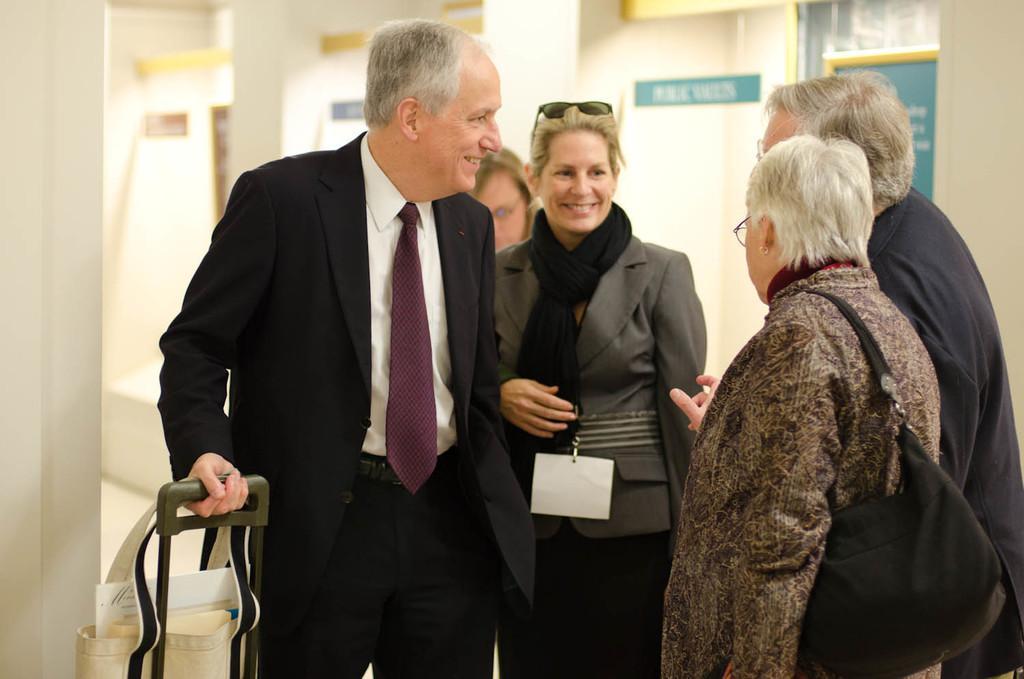Could you give a brief overview of what you see in this image? In this image there are people and bags in the foreground. And there are posters on the wall in the background. 